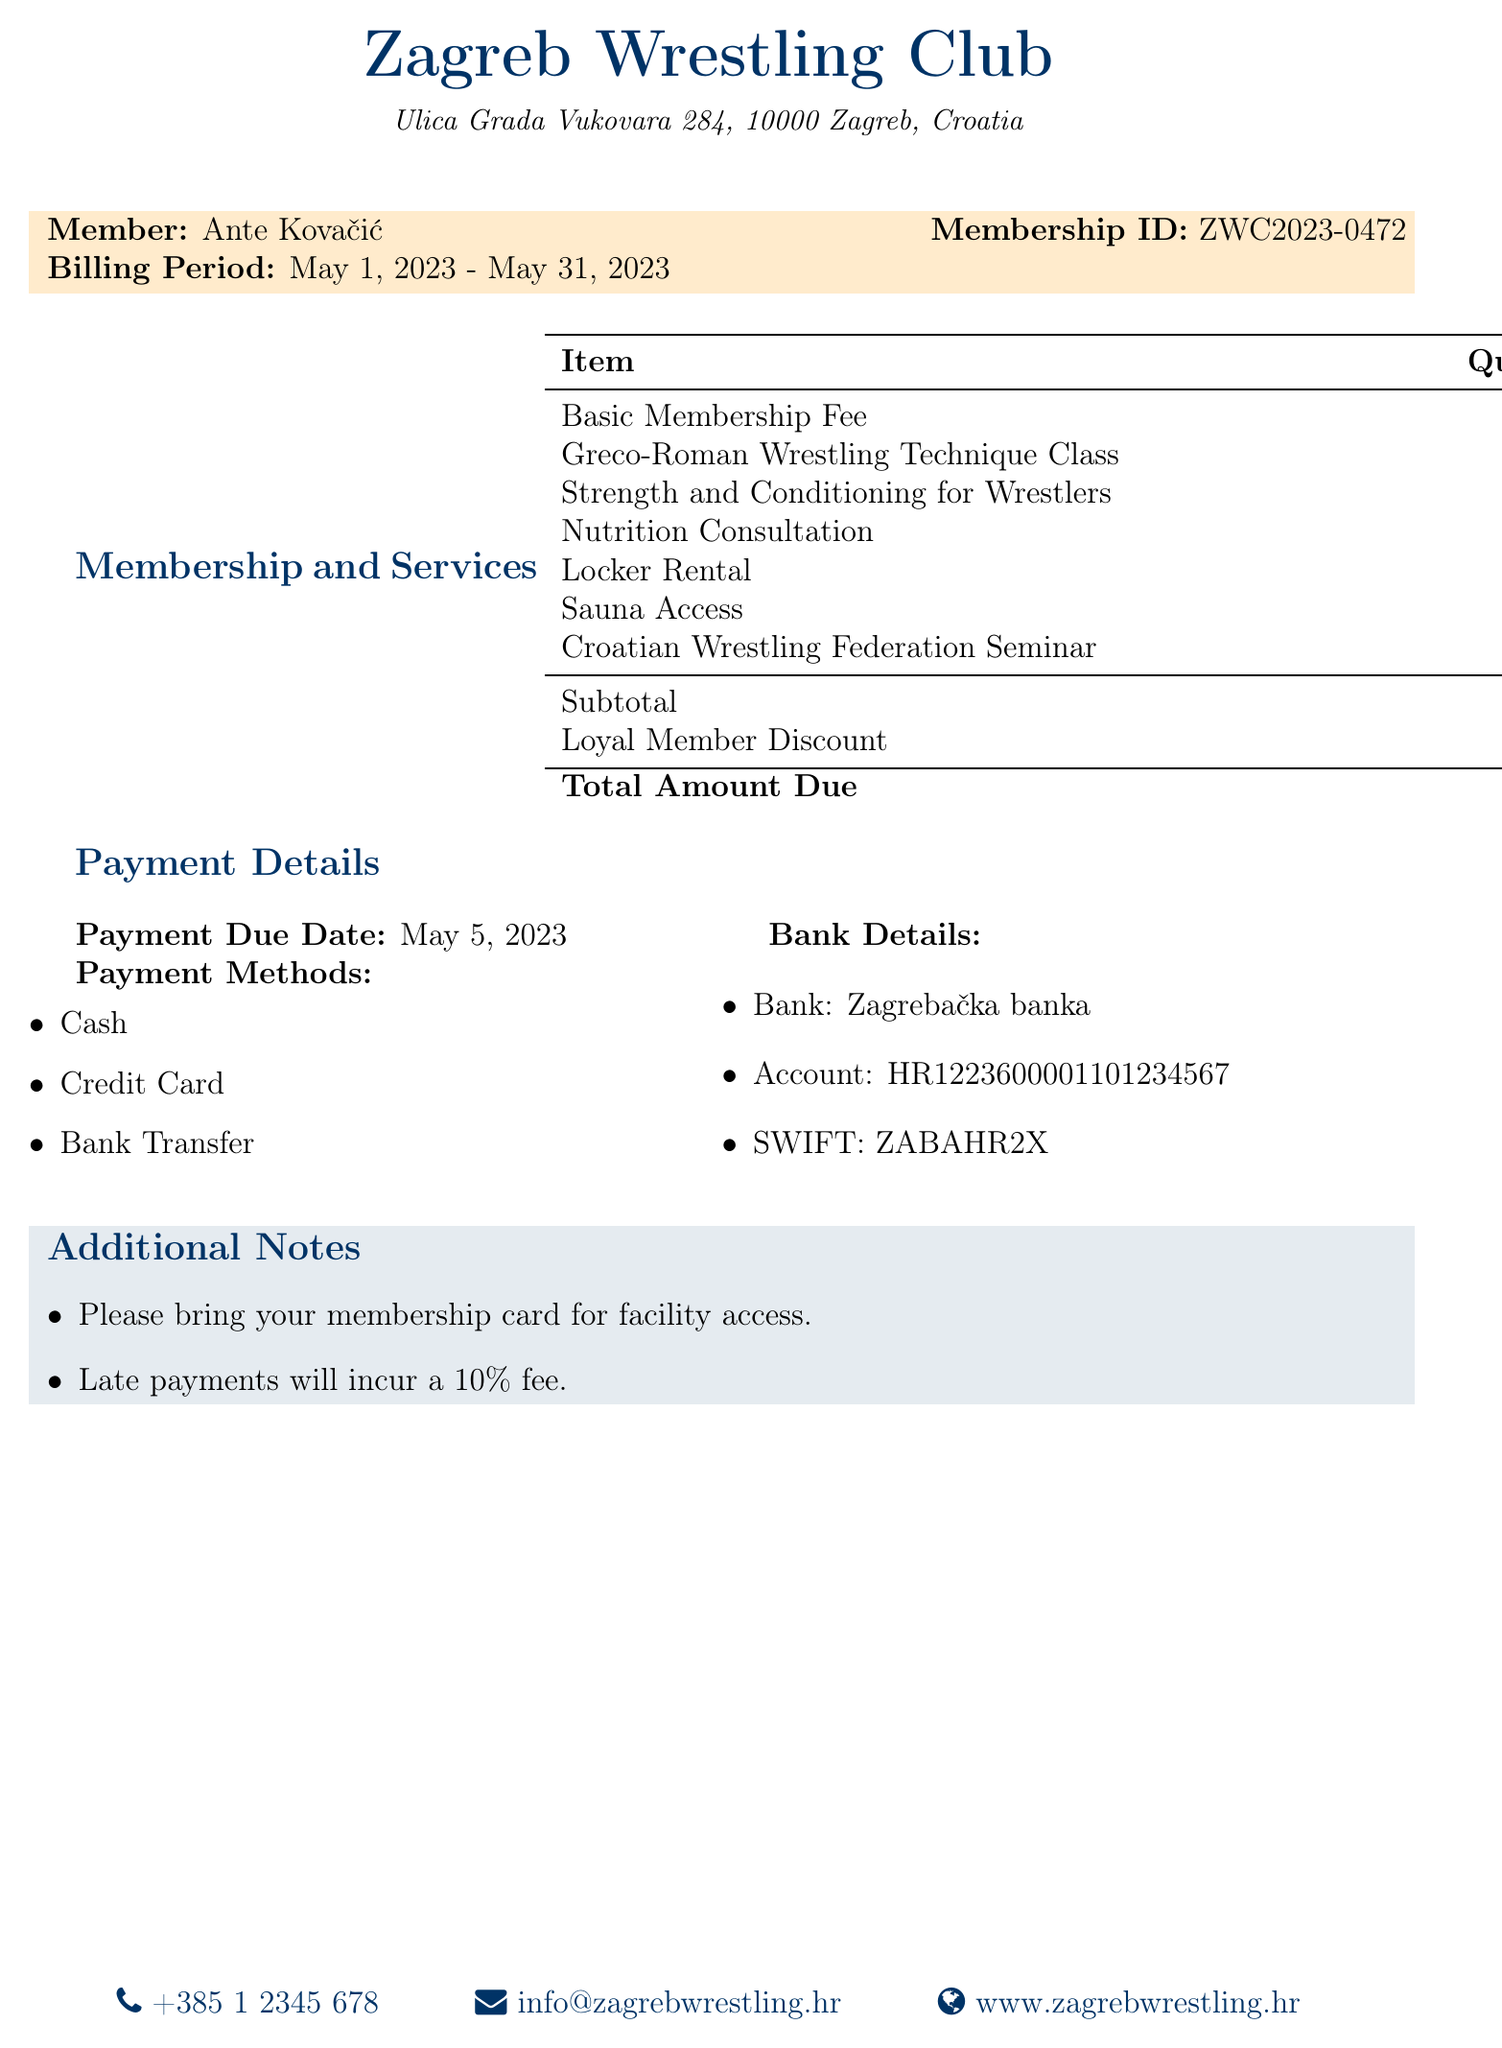What is the name of the gym? The name of the gym is prominently displayed at the top of the document.
Answer: Zagreb Wrestling Club What is the billing period? The billing period specifies the dates for which the membership fee is applicable.
Answer: May 1, 2023 - May 31, 2023 What is the total amount due? The total amount due is listed in the summary of costs at the bottom of the billing section.
Answer: 1,550.00 HRK How many sessions were attended for the Greco-Roman Wrestling Technique Class? The number of sessions is detailed next to each additional service provided in the document.
Answer: 4 What discount was applied to the total amount? The discount applied is noted in the itemized charges section of the bill.
Answer: 100.00 HRK What payment methods are available? Available payment methods are listed under the payment details section.
Answer: Cash, Credit Card, Bank Transfer When is the payment due date? The payment due date is clearly stated in the payment details section.
Answer: May 5, 2023 What is the price for the Nutrition Consultation? The price for the Nutrition Consultation is included in the additional services breakdown.
Answer: 200.00 HRK What is written in the additional notes section? The additional notes section mentions specific instructions for the member regarding facility access and late payments.
Answer: Please bring your membership card for facility access. Late payments will incur a 10% fee 